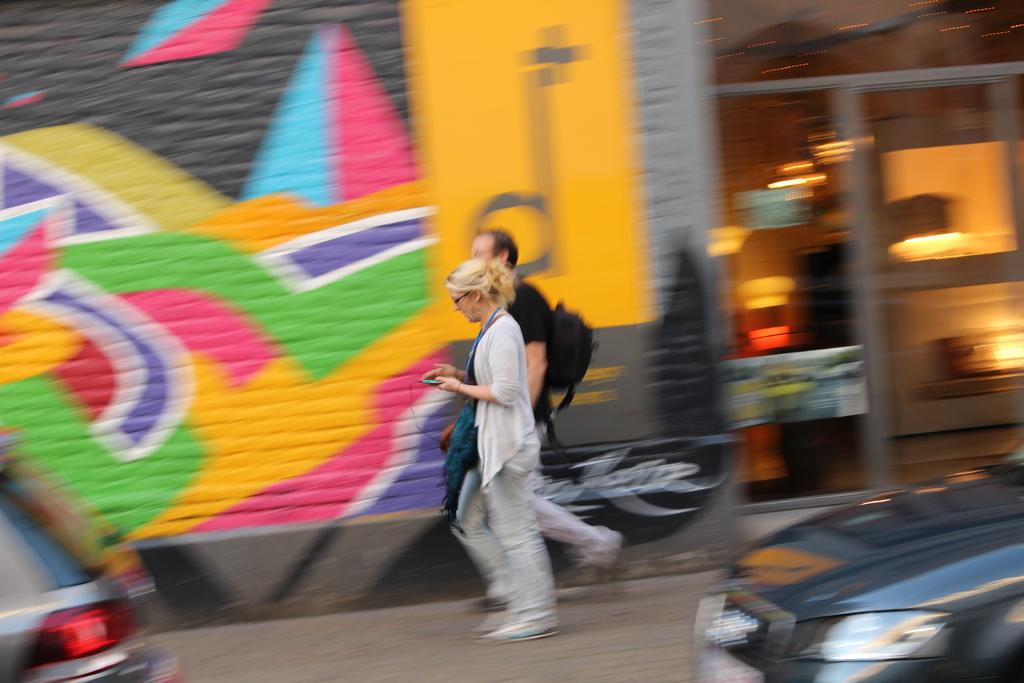What are the two people in the image doing? The two people in the image are walking in the center of the image. What can be seen at the bottom of the image? There are cars at the bottom of the image. What is visible in the background of the image? There is a building and a door visible in the background. What type of artwork can be seen on a wall in the image? There is graffiti on a wall in the image. What type of worm can be seen crawling on the wire in the image? There is no worm or wire present in the image. What type of writing can be seen on the building in the image? There is no writing visible on the building in the image; only graffiti is mentioned. 